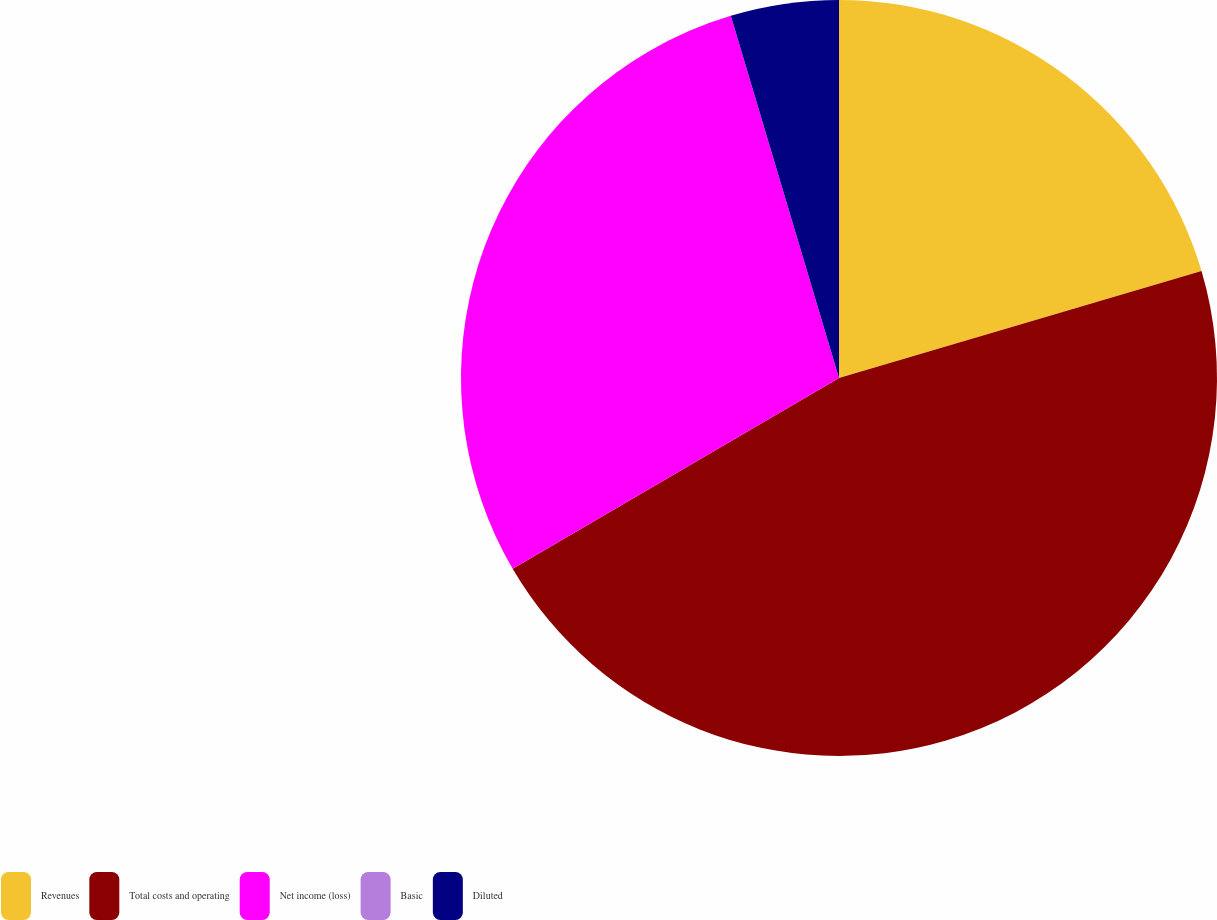Convert chart to OTSL. <chart><loc_0><loc_0><loc_500><loc_500><pie_chart><fcel>Revenues<fcel>Total costs and operating<fcel>Net income (loss)<fcel>Basic<fcel>Diluted<nl><fcel>20.43%<fcel>46.15%<fcel>28.8%<fcel>0.0%<fcel>4.62%<nl></chart> 